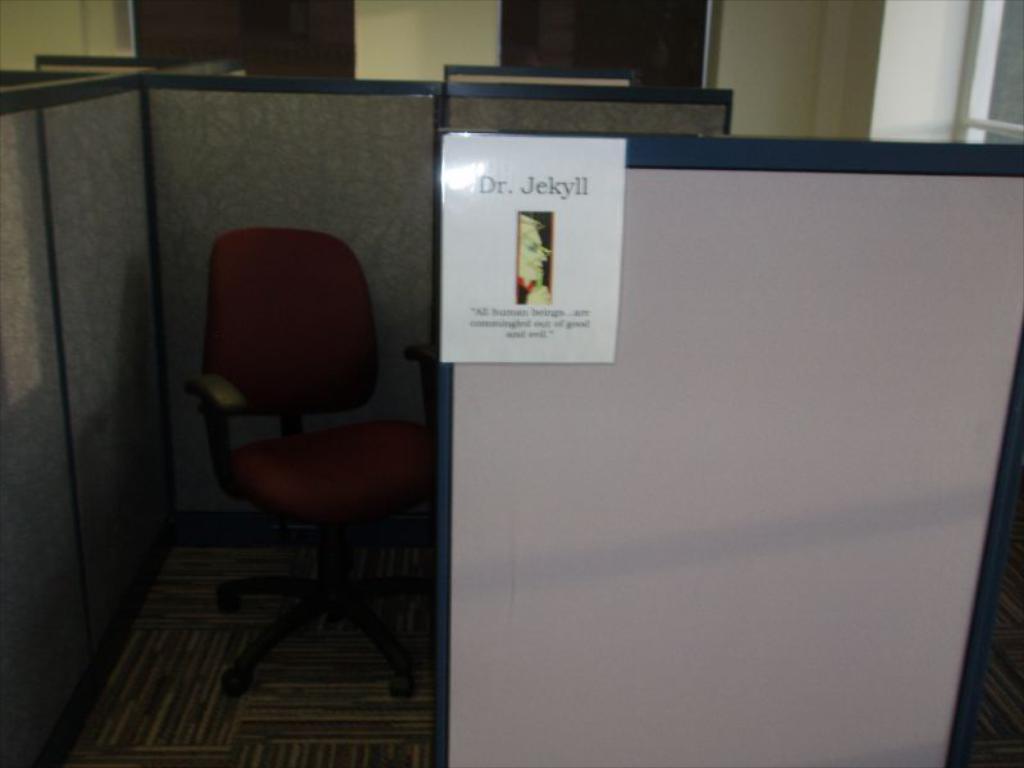What does that poster say?
Ensure brevity in your answer.  Dr. jekyll. 